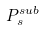<formula> <loc_0><loc_0><loc_500><loc_500>P _ { s } ^ { s u b }</formula> 